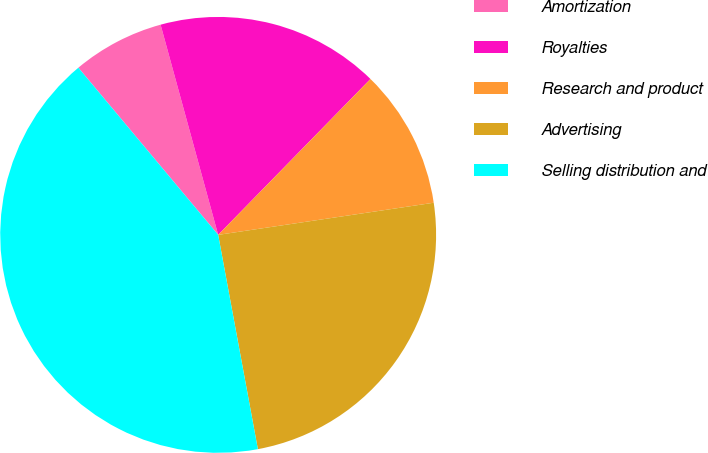Convert chart to OTSL. <chart><loc_0><loc_0><loc_500><loc_500><pie_chart><fcel>Amortization<fcel>Royalties<fcel>Research and product<fcel>Advertising<fcel>Selling distribution and<nl><fcel>6.83%<fcel>16.57%<fcel>10.33%<fcel>24.44%<fcel>41.83%<nl></chart> 